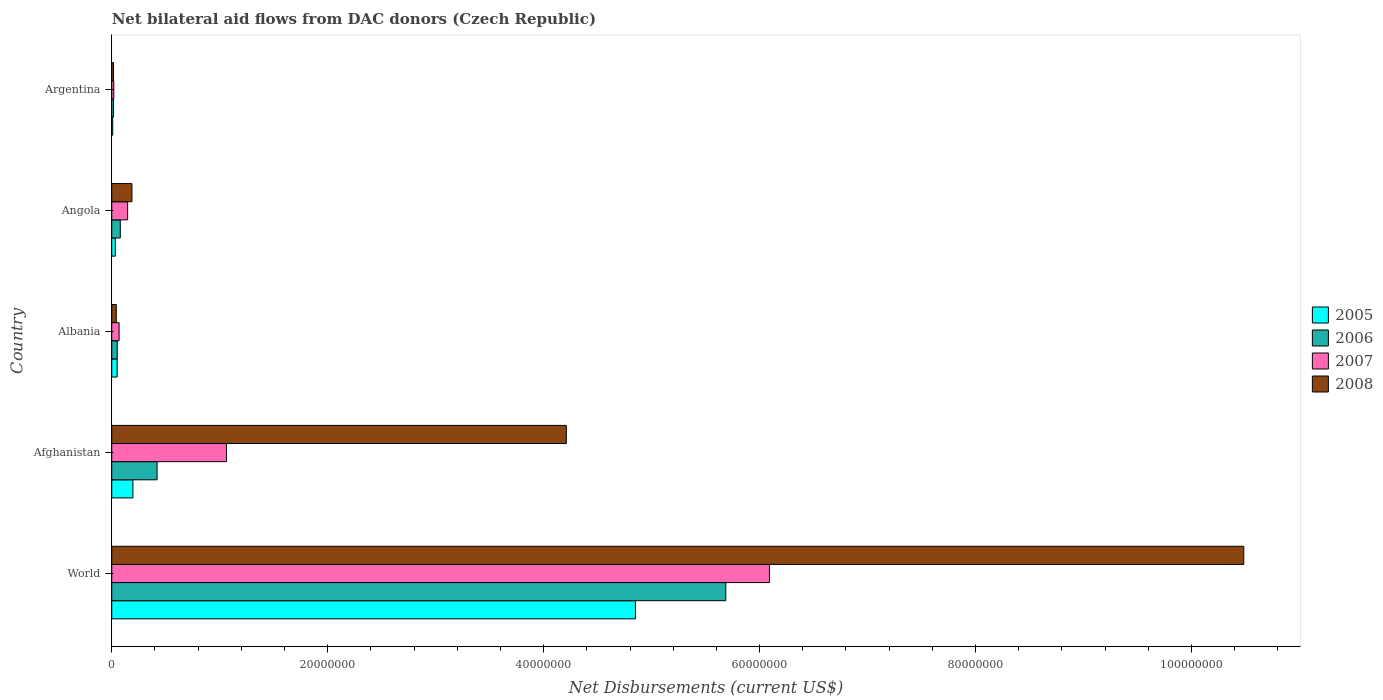How many groups of bars are there?
Your answer should be very brief. 5. What is the label of the 5th group of bars from the top?
Offer a very short reply. World. Across all countries, what is the maximum net bilateral aid flows in 2008?
Give a very brief answer. 1.05e+08. In which country was the net bilateral aid flows in 2008 maximum?
Offer a very short reply. World. In which country was the net bilateral aid flows in 2005 minimum?
Your answer should be very brief. Argentina. What is the total net bilateral aid flows in 2005 in the graph?
Keep it short and to the point. 5.14e+07. What is the difference between the net bilateral aid flows in 2006 in Argentina and that in World?
Your answer should be compact. -5.67e+07. What is the difference between the net bilateral aid flows in 2008 in Albania and the net bilateral aid flows in 2007 in Angola?
Provide a succinct answer. -1.05e+06. What is the average net bilateral aid flows in 2006 per country?
Offer a terse response. 1.25e+07. What is the difference between the net bilateral aid flows in 2005 and net bilateral aid flows in 2007 in World?
Give a very brief answer. -1.24e+07. What is the ratio of the net bilateral aid flows in 2006 in Afghanistan to that in Albania?
Your answer should be very brief. 8.24. What is the difference between the highest and the second highest net bilateral aid flows in 2008?
Ensure brevity in your answer.  6.27e+07. What is the difference between the highest and the lowest net bilateral aid flows in 2006?
Offer a terse response. 5.67e+07. In how many countries, is the net bilateral aid flows in 2007 greater than the average net bilateral aid flows in 2007 taken over all countries?
Provide a short and direct response. 1. Is it the case that in every country, the sum of the net bilateral aid flows in 2007 and net bilateral aid flows in 2008 is greater than the sum of net bilateral aid flows in 2006 and net bilateral aid flows in 2005?
Make the answer very short. No. Are all the bars in the graph horizontal?
Make the answer very short. Yes. How many countries are there in the graph?
Offer a very short reply. 5. Does the graph contain grids?
Offer a very short reply. No. How are the legend labels stacked?
Provide a succinct answer. Vertical. What is the title of the graph?
Offer a very short reply. Net bilateral aid flows from DAC donors (Czech Republic). Does "2010" appear as one of the legend labels in the graph?
Keep it short and to the point. No. What is the label or title of the X-axis?
Give a very brief answer. Net Disbursements (current US$). What is the Net Disbursements (current US$) in 2005 in World?
Your answer should be very brief. 4.85e+07. What is the Net Disbursements (current US$) in 2006 in World?
Give a very brief answer. 5.69e+07. What is the Net Disbursements (current US$) in 2007 in World?
Provide a succinct answer. 6.09e+07. What is the Net Disbursements (current US$) in 2008 in World?
Offer a very short reply. 1.05e+08. What is the Net Disbursements (current US$) of 2005 in Afghanistan?
Ensure brevity in your answer.  1.96e+06. What is the Net Disbursements (current US$) in 2006 in Afghanistan?
Provide a succinct answer. 4.20e+06. What is the Net Disbursements (current US$) in 2007 in Afghanistan?
Your answer should be very brief. 1.06e+07. What is the Net Disbursements (current US$) in 2008 in Afghanistan?
Keep it short and to the point. 4.21e+07. What is the Net Disbursements (current US$) in 2005 in Albania?
Your response must be concise. 5.00e+05. What is the Net Disbursements (current US$) in 2006 in Albania?
Your answer should be very brief. 5.10e+05. What is the Net Disbursements (current US$) in 2007 in Albania?
Offer a very short reply. 6.80e+05. What is the Net Disbursements (current US$) in 2005 in Angola?
Provide a succinct answer. 3.30e+05. What is the Net Disbursements (current US$) of 2006 in Angola?
Provide a short and direct response. 7.90e+05. What is the Net Disbursements (current US$) of 2007 in Angola?
Offer a very short reply. 1.47e+06. What is the Net Disbursements (current US$) of 2008 in Angola?
Your response must be concise. 1.87e+06. What is the Net Disbursements (current US$) in 2008 in Argentina?
Your answer should be compact. 1.60e+05. Across all countries, what is the maximum Net Disbursements (current US$) of 2005?
Your answer should be compact. 4.85e+07. Across all countries, what is the maximum Net Disbursements (current US$) of 2006?
Make the answer very short. 5.69e+07. Across all countries, what is the maximum Net Disbursements (current US$) in 2007?
Offer a very short reply. 6.09e+07. Across all countries, what is the maximum Net Disbursements (current US$) of 2008?
Your answer should be very brief. 1.05e+08. Across all countries, what is the minimum Net Disbursements (current US$) in 2005?
Make the answer very short. 9.00e+04. Across all countries, what is the minimum Net Disbursements (current US$) of 2007?
Your response must be concise. 1.90e+05. What is the total Net Disbursements (current US$) in 2005 in the graph?
Offer a very short reply. 5.14e+07. What is the total Net Disbursements (current US$) of 2006 in the graph?
Offer a terse response. 6.25e+07. What is the total Net Disbursements (current US$) in 2007 in the graph?
Your answer should be compact. 7.39e+07. What is the total Net Disbursements (current US$) in 2008 in the graph?
Provide a succinct answer. 1.49e+08. What is the difference between the Net Disbursements (current US$) of 2005 in World and that in Afghanistan?
Your answer should be very brief. 4.65e+07. What is the difference between the Net Disbursements (current US$) of 2006 in World and that in Afghanistan?
Your answer should be compact. 5.27e+07. What is the difference between the Net Disbursements (current US$) of 2007 in World and that in Afghanistan?
Offer a terse response. 5.03e+07. What is the difference between the Net Disbursements (current US$) in 2008 in World and that in Afghanistan?
Ensure brevity in your answer.  6.27e+07. What is the difference between the Net Disbursements (current US$) of 2005 in World and that in Albania?
Ensure brevity in your answer.  4.80e+07. What is the difference between the Net Disbursements (current US$) in 2006 in World and that in Albania?
Your response must be concise. 5.64e+07. What is the difference between the Net Disbursements (current US$) in 2007 in World and that in Albania?
Your answer should be very brief. 6.02e+07. What is the difference between the Net Disbursements (current US$) of 2008 in World and that in Albania?
Provide a short and direct response. 1.04e+08. What is the difference between the Net Disbursements (current US$) of 2005 in World and that in Angola?
Offer a terse response. 4.82e+07. What is the difference between the Net Disbursements (current US$) in 2006 in World and that in Angola?
Offer a very short reply. 5.61e+07. What is the difference between the Net Disbursements (current US$) of 2007 in World and that in Angola?
Provide a succinct answer. 5.94e+07. What is the difference between the Net Disbursements (current US$) in 2008 in World and that in Angola?
Provide a succinct answer. 1.03e+08. What is the difference between the Net Disbursements (current US$) in 2005 in World and that in Argentina?
Offer a very short reply. 4.84e+07. What is the difference between the Net Disbursements (current US$) in 2006 in World and that in Argentina?
Offer a very short reply. 5.67e+07. What is the difference between the Net Disbursements (current US$) in 2007 in World and that in Argentina?
Keep it short and to the point. 6.07e+07. What is the difference between the Net Disbursements (current US$) in 2008 in World and that in Argentina?
Give a very brief answer. 1.05e+08. What is the difference between the Net Disbursements (current US$) in 2005 in Afghanistan and that in Albania?
Provide a short and direct response. 1.46e+06. What is the difference between the Net Disbursements (current US$) of 2006 in Afghanistan and that in Albania?
Make the answer very short. 3.69e+06. What is the difference between the Net Disbursements (current US$) in 2007 in Afghanistan and that in Albania?
Give a very brief answer. 9.94e+06. What is the difference between the Net Disbursements (current US$) in 2008 in Afghanistan and that in Albania?
Your response must be concise. 4.17e+07. What is the difference between the Net Disbursements (current US$) of 2005 in Afghanistan and that in Angola?
Your answer should be compact. 1.63e+06. What is the difference between the Net Disbursements (current US$) in 2006 in Afghanistan and that in Angola?
Give a very brief answer. 3.41e+06. What is the difference between the Net Disbursements (current US$) of 2007 in Afghanistan and that in Angola?
Provide a succinct answer. 9.15e+06. What is the difference between the Net Disbursements (current US$) in 2008 in Afghanistan and that in Angola?
Your response must be concise. 4.02e+07. What is the difference between the Net Disbursements (current US$) of 2005 in Afghanistan and that in Argentina?
Offer a very short reply. 1.87e+06. What is the difference between the Net Disbursements (current US$) of 2006 in Afghanistan and that in Argentina?
Offer a terse response. 4.04e+06. What is the difference between the Net Disbursements (current US$) in 2007 in Afghanistan and that in Argentina?
Your response must be concise. 1.04e+07. What is the difference between the Net Disbursements (current US$) of 2008 in Afghanistan and that in Argentina?
Provide a succinct answer. 4.19e+07. What is the difference between the Net Disbursements (current US$) of 2005 in Albania and that in Angola?
Offer a very short reply. 1.70e+05. What is the difference between the Net Disbursements (current US$) in 2006 in Albania and that in Angola?
Offer a very short reply. -2.80e+05. What is the difference between the Net Disbursements (current US$) in 2007 in Albania and that in Angola?
Your response must be concise. -7.90e+05. What is the difference between the Net Disbursements (current US$) in 2008 in Albania and that in Angola?
Give a very brief answer. -1.45e+06. What is the difference between the Net Disbursements (current US$) of 2005 in Albania and that in Argentina?
Offer a very short reply. 4.10e+05. What is the difference between the Net Disbursements (current US$) of 2007 in Albania and that in Argentina?
Offer a terse response. 4.90e+05. What is the difference between the Net Disbursements (current US$) in 2008 in Albania and that in Argentina?
Ensure brevity in your answer.  2.60e+05. What is the difference between the Net Disbursements (current US$) of 2006 in Angola and that in Argentina?
Make the answer very short. 6.30e+05. What is the difference between the Net Disbursements (current US$) of 2007 in Angola and that in Argentina?
Keep it short and to the point. 1.28e+06. What is the difference between the Net Disbursements (current US$) in 2008 in Angola and that in Argentina?
Your response must be concise. 1.71e+06. What is the difference between the Net Disbursements (current US$) of 2005 in World and the Net Disbursements (current US$) of 2006 in Afghanistan?
Offer a terse response. 4.43e+07. What is the difference between the Net Disbursements (current US$) of 2005 in World and the Net Disbursements (current US$) of 2007 in Afghanistan?
Offer a very short reply. 3.79e+07. What is the difference between the Net Disbursements (current US$) of 2005 in World and the Net Disbursements (current US$) of 2008 in Afghanistan?
Make the answer very short. 6.40e+06. What is the difference between the Net Disbursements (current US$) in 2006 in World and the Net Disbursements (current US$) in 2007 in Afghanistan?
Give a very brief answer. 4.62e+07. What is the difference between the Net Disbursements (current US$) of 2006 in World and the Net Disbursements (current US$) of 2008 in Afghanistan?
Your answer should be compact. 1.48e+07. What is the difference between the Net Disbursements (current US$) in 2007 in World and the Net Disbursements (current US$) in 2008 in Afghanistan?
Your answer should be compact. 1.88e+07. What is the difference between the Net Disbursements (current US$) of 2005 in World and the Net Disbursements (current US$) of 2006 in Albania?
Your response must be concise. 4.80e+07. What is the difference between the Net Disbursements (current US$) of 2005 in World and the Net Disbursements (current US$) of 2007 in Albania?
Provide a succinct answer. 4.78e+07. What is the difference between the Net Disbursements (current US$) in 2005 in World and the Net Disbursements (current US$) in 2008 in Albania?
Offer a terse response. 4.81e+07. What is the difference between the Net Disbursements (current US$) of 2006 in World and the Net Disbursements (current US$) of 2007 in Albania?
Keep it short and to the point. 5.62e+07. What is the difference between the Net Disbursements (current US$) of 2006 in World and the Net Disbursements (current US$) of 2008 in Albania?
Offer a very short reply. 5.64e+07. What is the difference between the Net Disbursements (current US$) of 2007 in World and the Net Disbursements (current US$) of 2008 in Albania?
Your answer should be compact. 6.05e+07. What is the difference between the Net Disbursements (current US$) of 2005 in World and the Net Disbursements (current US$) of 2006 in Angola?
Provide a short and direct response. 4.77e+07. What is the difference between the Net Disbursements (current US$) of 2005 in World and the Net Disbursements (current US$) of 2007 in Angola?
Provide a succinct answer. 4.70e+07. What is the difference between the Net Disbursements (current US$) in 2005 in World and the Net Disbursements (current US$) in 2008 in Angola?
Your response must be concise. 4.66e+07. What is the difference between the Net Disbursements (current US$) of 2006 in World and the Net Disbursements (current US$) of 2007 in Angola?
Keep it short and to the point. 5.54e+07. What is the difference between the Net Disbursements (current US$) in 2006 in World and the Net Disbursements (current US$) in 2008 in Angola?
Offer a very short reply. 5.50e+07. What is the difference between the Net Disbursements (current US$) of 2007 in World and the Net Disbursements (current US$) of 2008 in Angola?
Offer a very short reply. 5.90e+07. What is the difference between the Net Disbursements (current US$) in 2005 in World and the Net Disbursements (current US$) in 2006 in Argentina?
Ensure brevity in your answer.  4.83e+07. What is the difference between the Net Disbursements (current US$) in 2005 in World and the Net Disbursements (current US$) in 2007 in Argentina?
Keep it short and to the point. 4.83e+07. What is the difference between the Net Disbursements (current US$) in 2005 in World and the Net Disbursements (current US$) in 2008 in Argentina?
Provide a succinct answer. 4.83e+07. What is the difference between the Net Disbursements (current US$) in 2006 in World and the Net Disbursements (current US$) in 2007 in Argentina?
Your answer should be compact. 5.67e+07. What is the difference between the Net Disbursements (current US$) in 2006 in World and the Net Disbursements (current US$) in 2008 in Argentina?
Your response must be concise. 5.67e+07. What is the difference between the Net Disbursements (current US$) of 2007 in World and the Net Disbursements (current US$) of 2008 in Argentina?
Offer a terse response. 6.08e+07. What is the difference between the Net Disbursements (current US$) of 2005 in Afghanistan and the Net Disbursements (current US$) of 2006 in Albania?
Ensure brevity in your answer.  1.45e+06. What is the difference between the Net Disbursements (current US$) of 2005 in Afghanistan and the Net Disbursements (current US$) of 2007 in Albania?
Offer a very short reply. 1.28e+06. What is the difference between the Net Disbursements (current US$) of 2005 in Afghanistan and the Net Disbursements (current US$) of 2008 in Albania?
Provide a succinct answer. 1.54e+06. What is the difference between the Net Disbursements (current US$) of 2006 in Afghanistan and the Net Disbursements (current US$) of 2007 in Albania?
Your answer should be very brief. 3.52e+06. What is the difference between the Net Disbursements (current US$) of 2006 in Afghanistan and the Net Disbursements (current US$) of 2008 in Albania?
Offer a very short reply. 3.78e+06. What is the difference between the Net Disbursements (current US$) of 2007 in Afghanistan and the Net Disbursements (current US$) of 2008 in Albania?
Ensure brevity in your answer.  1.02e+07. What is the difference between the Net Disbursements (current US$) in 2005 in Afghanistan and the Net Disbursements (current US$) in 2006 in Angola?
Your answer should be very brief. 1.17e+06. What is the difference between the Net Disbursements (current US$) of 2005 in Afghanistan and the Net Disbursements (current US$) of 2008 in Angola?
Your answer should be very brief. 9.00e+04. What is the difference between the Net Disbursements (current US$) in 2006 in Afghanistan and the Net Disbursements (current US$) in 2007 in Angola?
Your response must be concise. 2.73e+06. What is the difference between the Net Disbursements (current US$) of 2006 in Afghanistan and the Net Disbursements (current US$) of 2008 in Angola?
Provide a succinct answer. 2.33e+06. What is the difference between the Net Disbursements (current US$) of 2007 in Afghanistan and the Net Disbursements (current US$) of 2008 in Angola?
Offer a terse response. 8.75e+06. What is the difference between the Net Disbursements (current US$) in 2005 in Afghanistan and the Net Disbursements (current US$) in 2006 in Argentina?
Provide a succinct answer. 1.80e+06. What is the difference between the Net Disbursements (current US$) of 2005 in Afghanistan and the Net Disbursements (current US$) of 2007 in Argentina?
Provide a succinct answer. 1.77e+06. What is the difference between the Net Disbursements (current US$) of 2005 in Afghanistan and the Net Disbursements (current US$) of 2008 in Argentina?
Offer a terse response. 1.80e+06. What is the difference between the Net Disbursements (current US$) of 2006 in Afghanistan and the Net Disbursements (current US$) of 2007 in Argentina?
Offer a very short reply. 4.01e+06. What is the difference between the Net Disbursements (current US$) in 2006 in Afghanistan and the Net Disbursements (current US$) in 2008 in Argentina?
Your response must be concise. 4.04e+06. What is the difference between the Net Disbursements (current US$) of 2007 in Afghanistan and the Net Disbursements (current US$) of 2008 in Argentina?
Your answer should be compact. 1.05e+07. What is the difference between the Net Disbursements (current US$) in 2005 in Albania and the Net Disbursements (current US$) in 2007 in Angola?
Give a very brief answer. -9.70e+05. What is the difference between the Net Disbursements (current US$) in 2005 in Albania and the Net Disbursements (current US$) in 2008 in Angola?
Ensure brevity in your answer.  -1.37e+06. What is the difference between the Net Disbursements (current US$) of 2006 in Albania and the Net Disbursements (current US$) of 2007 in Angola?
Your answer should be compact. -9.60e+05. What is the difference between the Net Disbursements (current US$) of 2006 in Albania and the Net Disbursements (current US$) of 2008 in Angola?
Your response must be concise. -1.36e+06. What is the difference between the Net Disbursements (current US$) of 2007 in Albania and the Net Disbursements (current US$) of 2008 in Angola?
Provide a succinct answer. -1.19e+06. What is the difference between the Net Disbursements (current US$) in 2005 in Albania and the Net Disbursements (current US$) in 2006 in Argentina?
Ensure brevity in your answer.  3.40e+05. What is the difference between the Net Disbursements (current US$) in 2005 in Albania and the Net Disbursements (current US$) in 2007 in Argentina?
Make the answer very short. 3.10e+05. What is the difference between the Net Disbursements (current US$) of 2006 in Albania and the Net Disbursements (current US$) of 2008 in Argentina?
Your response must be concise. 3.50e+05. What is the difference between the Net Disbursements (current US$) of 2007 in Albania and the Net Disbursements (current US$) of 2008 in Argentina?
Your response must be concise. 5.20e+05. What is the difference between the Net Disbursements (current US$) of 2005 in Angola and the Net Disbursements (current US$) of 2006 in Argentina?
Your answer should be compact. 1.70e+05. What is the difference between the Net Disbursements (current US$) in 2005 in Angola and the Net Disbursements (current US$) in 2007 in Argentina?
Provide a short and direct response. 1.40e+05. What is the difference between the Net Disbursements (current US$) of 2005 in Angola and the Net Disbursements (current US$) of 2008 in Argentina?
Offer a very short reply. 1.70e+05. What is the difference between the Net Disbursements (current US$) of 2006 in Angola and the Net Disbursements (current US$) of 2008 in Argentina?
Offer a very short reply. 6.30e+05. What is the difference between the Net Disbursements (current US$) in 2007 in Angola and the Net Disbursements (current US$) in 2008 in Argentina?
Your answer should be compact. 1.31e+06. What is the average Net Disbursements (current US$) in 2005 per country?
Make the answer very short. 1.03e+07. What is the average Net Disbursements (current US$) in 2006 per country?
Ensure brevity in your answer.  1.25e+07. What is the average Net Disbursements (current US$) in 2007 per country?
Keep it short and to the point. 1.48e+07. What is the average Net Disbursements (current US$) in 2008 per country?
Your answer should be very brief. 2.99e+07. What is the difference between the Net Disbursements (current US$) of 2005 and Net Disbursements (current US$) of 2006 in World?
Provide a short and direct response. -8.37e+06. What is the difference between the Net Disbursements (current US$) in 2005 and Net Disbursements (current US$) in 2007 in World?
Your answer should be very brief. -1.24e+07. What is the difference between the Net Disbursements (current US$) of 2005 and Net Disbursements (current US$) of 2008 in World?
Offer a very short reply. -5.63e+07. What is the difference between the Net Disbursements (current US$) of 2006 and Net Disbursements (current US$) of 2007 in World?
Make the answer very short. -4.04e+06. What is the difference between the Net Disbursements (current US$) in 2006 and Net Disbursements (current US$) in 2008 in World?
Offer a terse response. -4.80e+07. What is the difference between the Net Disbursements (current US$) in 2007 and Net Disbursements (current US$) in 2008 in World?
Keep it short and to the point. -4.39e+07. What is the difference between the Net Disbursements (current US$) in 2005 and Net Disbursements (current US$) in 2006 in Afghanistan?
Your response must be concise. -2.24e+06. What is the difference between the Net Disbursements (current US$) of 2005 and Net Disbursements (current US$) of 2007 in Afghanistan?
Your answer should be compact. -8.66e+06. What is the difference between the Net Disbursements (current US$) in 2005 and Net Disbursements (current US$) in 2008 in Afghanistan?
Your answer should be compact. -4.01e+07. What is the difference between the Net Disbursements (current US$) of 2006 and Net Disbursements (current US$) of 2007 in Afghanistan?
Provide a short and direct response. -6.42e+06. What is the difference between the Net Disbursements (current US$) of 2006 and Net Disbursements (current US$) of 2008 in Afghanistan?
Keep it short and to the point. -3.79e+07. What is the difference between the Net Disbursements (current US$) of 2007 and Net Disbursements (current US$) of 2008 in Afghanistan?
Provide a short and direct response. -3.15e+07. What is the difference between the Net Disbursements (current US$) in 2005 and Net Disbursements (current US$) in 2007 in Albania?
Offer a terse response. -1.80e+05. What is the difference between the Net Disbursements (current US$) in 2006 and Net Disbursements (current US$) in 2007 in Albania?
Your answer should be compact. -1.70e+05. What is the difference between the Net Disbursements (current US$) of 2006 and Net Disbursements (current US$) of 2008 in Albania?
Your answer should be compact. 9.00e+04. What is the difference between the Net Disbursements (current US$) of 2007 and Net Disbursements (current US$) of 2008 in Albania?
Provide a succinct answer. 2.60e+05. What is the difference between the Net Disbursements (current US$) in 2005 and Net Disbursements (current US$) in 2006 in Angola?
Provide a short and direct response. -4.60e+05. What is the difference between the Net Disbursements (current US$) in 2005 and Net Disbursements (current US$) in 2007 in Angola?
Offer a terse response. -1.14e+06. What is the difference between the Net Disbursements (current US$) of 2005 and Net Disbursements (current US$) of 2008 in Angola?
Your response must be concise. -1.54e+06. What is the difference between the Net Disbursements (current US$) in 2006 and Net Disbursements (current US$) in 2007 in Angola?
Provide a short and direct response. -6.80e+05. What is the difference between the Net Disbursements (current US$) in 2006 and Net Disbursements (current US$) in 2008 in Angola?
Your response must be concise. -1.08e+06. What is the difference between the Net Disbursements (current US$) of 2007 and Net Disbursements (current US$) of 2008 in Angola?
Offer a terse response. -4.00e+05. What is the difference between the Net Disbursements (current US$) of 2005 and Net Disbursements (current US$) of 2007 in Argentina?
Provide a succinct answer. -1.00e+05. What is the difference between the Net Disbursements (current US$) of 2005 and Net Disbursements (current US$) of 2008 in Argentina?
Give a very brief answer. -7.00e+04. What is the difference between the Net Disbursements (current US$) of 2006 and Net Disbursements (current US$) of 2007 in Argentina?
Your answer should be compact. -3.00e+04. What is the ratio of the Net Disbursements (current US$) of 2005 in World to that in Afghanistan?
Offer a terse response. 24.74. What is the ratio of the Net Disbursements (current US$) of 2006 in World to that in Afghanistan?
Your response must be concise. 13.54. What is the ratio of the Net Disbursements (current US$) in 2007 in World to that in Afghanistan?
Your response must be concise. 5.74. What is the ratio of the Net Disbursements (current US$) of 2008 in World to that in Afghanistan?
Ensure brevity in your answer.  2.49. What is the ratio of the Net Disbursements (current US$) of 2005 in World to that in Albania?
Your answer should be very brief. 97. What is the ratio of the Net Disbursements (current US$) of 2006 in World to that in Albania?
Provide a short and direct response. 111.51. What is the ratio of the Net Disbursements (current US$) of 2007 in World to that in Albania?
Your answer should be compact. 89.57. What is the ratio of the Net Disbursements (current US$) in 2008 in World to that in Albania?
Offer a very short reply. 249.62. What is the ratio of the Net Disbursements (current US$) in 2005 in World to that in Angola?
Offer a very short reply. 146.97. What is the ratio of the Net Disbursements (current US$) of 2006 in World to that in Angola?
Provide a short and direct response. 71.99. What is the ratio of the Net Disbursements (current US$) in 2007 in World to that in Angola?
Ensure brevity in your answer.  41.44. What is the ratio of the Net Disbursements (current US$) of 2008 in World to that in Angola?
Give a very brief answer. 56.06. What is the ratio of the Net Disbursements (current US$) of 2005 in World to that in Argentina?
Provide a short and direct response. 538.89. What is the ratio of the Net Disbursements (current US$) of 2006 in World to that in Argentina?
Provide a succinct answer. 355.44. What is the ratio of the Net Disbursements (current US$) of 2007 in World to that in Argentina?
Ensure brevity in your answer.  320.58. What is the ratio of the Net Disbursements (current US$) in 2008 in World to that in Argentina?
Provide a short and direct response. 655.25. What is the ratio of the Net Disbursements (current US$) of 2005 in Afghanistan to that in Albania?
Your answer should be very brief. 3.92. What is the ratio of the Net Disbursements (current US$) of 2006 in Afghanistan to that in Albania?
Make the answer very short. 8.24. What is the ratio of the Net Disbursements (current US$) in 2007 in Afghanistan to that in Albania?
Your answer should be compact. 15.62. What is the ratio of the Net Disbursements (current US$) in 2008 in Afghanistan to that in Albania?
Offer a very short reply. 100.24. What is the ratio of the Net Disbursements (current US$) in 2005 in Afghanistan to that in Angola?
Offer a terse response. 5.94. What is the ratio of the Net Disbursements (current US$) in 2006 in Afghanistan to that in Angola?
Offer a very short reply. 5.32. What is the ratio of the Net Disbursements (current US$) of 2007 in Afghanistan to that in Angola?
Keep it short and to the point. 7.22. What is the ratio of the Net Disbursements (current US$) of 2008 in Afghanistan to that in Angola?
Offer a very short reply. 22.51. What is the ratio of the Net Disbursements (current US$) of 2005 in Afghanistan to that in Argentina?
Offer a terse response. 21.78. What is the ratio of the Net Disbursements (current US$) in 2006 in Afghanistan to that in Argentina?
Your response must be concise. 26.25. What is the ratio of the Net Disbursements (current US$) in 2007 in Afghanistan to that in Argentina?
Make the answer very short. 55.89. What is the ratio of the Net Disbursements (current US$) in 2008 in Afghanistan to that in Argentina?
Your answer should be compact. 263.12. What is the ratio of the Net Disbursements (current US$) in 2005 in Albania to that in Angola?
Provide a short and direct response. 1.52. What is the ratio of the Net Disbursements (current US$) in 2006 in Albania to that in Angola?
Give a very brief answer. 0.65. What is the ratio of the Net Disbursements (current US$) in 2007 in Albania to that in Angola?
Your answer should be compact. 0.46. What is the ratio of the Net Disbursements (current US$) in 2008 in Albania to that in Angola?
Keep it short and to the point. 0.22. What is the ratio of the Net Disbursements (current US$) of 2005 in Albania to that in Argentina?
Your response must be concise. 5.56. What is the ratio of the Net Disbursements (current US$) in 2006 in Albania to that in Argentina?
Keep it short and to the point. 3.19. What is the ratio of the Net Disbursements (current US$) in 2007 in Albania to that in Argentina?
Offer a terse response. 3.58. What is the ratio of the Net Disbursements (current US$) in 2008 in Albania to that in Argentina?
Keep it short and to the point. 2.62. What is the ratio of the Net Disbursements (current US$) of 2005 in Angola to that in Argentina?
Ensure brevity in your answer.  3.67. What is the ratio of the Net Disbursements (current US$) in 2006 in Angola to that in Argentina?
Keep it short and to the point. 4.94. What is the ratio of the Net Disbursements (current US$) in 2007 in Angola to that in Argentina?
Offer a terse response. 7.74. What is the ratio of the Net Disbursements (current US$) of 2008 in Angola to that in Argentina?
Provide a short and direct response. 11.69. What is the difference between the highest and the second highest Net Disbursements (current US$) in 2005?
Ensure brevity in your answer.  4.65e+07. What is the difference between the highest and the second highest Net Disbursements (current US$) in 2006?
Provide a succinct answer. 5.27e+07. What is the difference between the highest and the second highest Net Disbursements (current US$) of 2007?
Provide a short and direct response. 5.03e+07. What is the difference between the highest and the second highest Net Disbursements (current US$) in 2008?
Keep it short and to the point. 6.27e+07. What is the difference between the highest and the lowest Net Disbursements (current US$) in 2005?
Give a very brief answer. 4.84e+07. What is the difference between the highest and the lowest Net Disbursements (current US$) in 2006?
Keep it short and to the point. 5.67e+07. What is the difference between the highest and the lowest Net Disbursements (current US$) in 2007?
Make the answer very short. 6.07e+07. What is the difference between the highest and the lowest Net Disbursements (current US$) in 2008?
Offer a terse response. 1.05e+08. 